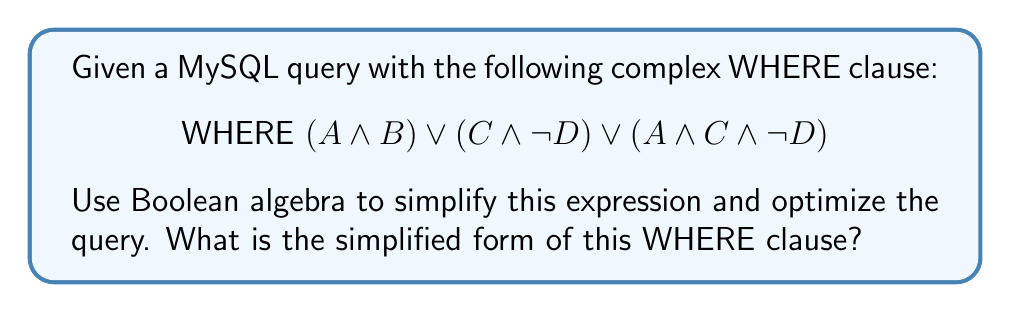Could you help me with this problem? Let's simplify this expression step by step using Boolean algebra laws:

1) First, let's identify the common terms:
   $$(A \land B) \lor (C \land \lnot D) \lor (A \land C \land \lnot D)$$

2) We can factor out $(C \land \lnot D)$ from the last two terms:
   $$(A \land B) \lor ((C \land \lnot D) \lor (A \land C \land \lnot D))$$
   $$(A \land B) \lor ((C \land \lnot D) \land (1 \lor A))$$

3) Using the absorption law $(X \lor (X \land Y) = X)$, we can simplify $(1 \lor A)$ to 1:
   $$(A \land B) \lor (C \land \lnot D)$$

4) This is already in its simplest form. We can't combine these terms further because they don't share common factors.

The simplified WHERE clause is equivalent to the original but requires fewer operations, potentially improving query performance.
Answer: $$\text{WHERE } (A \land B) \lor (C \land \lnot D)$$ 